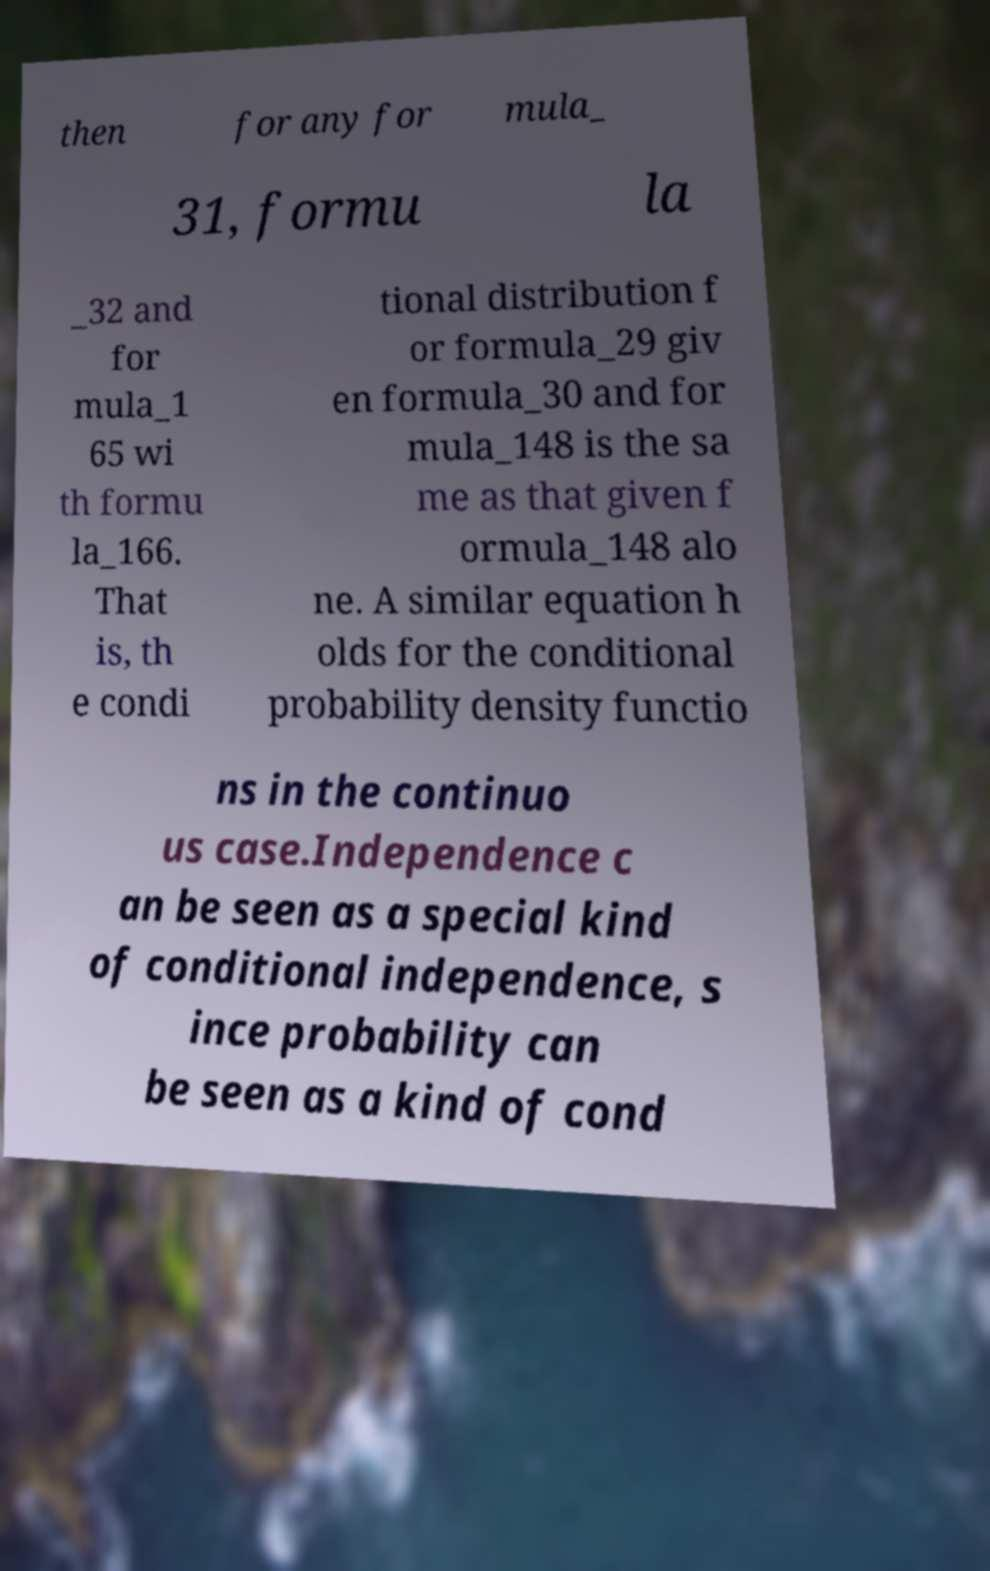Please read and relay the text visible in this image. What does it say? then for any for mula_ 31, formu la _32 and for mula_1 65 wi th formu la_166. That is, th e condi tional distribution f or formula_29 giv en formula_30 and for mula_148 is the sa me as that given f ormula_148 alo ne. A similar equation h olds for the conditional probability density functio ns in the continuo us case.Independence c an be seen as a special kind of conditional independence, s ince probability can be seen as a kind of cond 